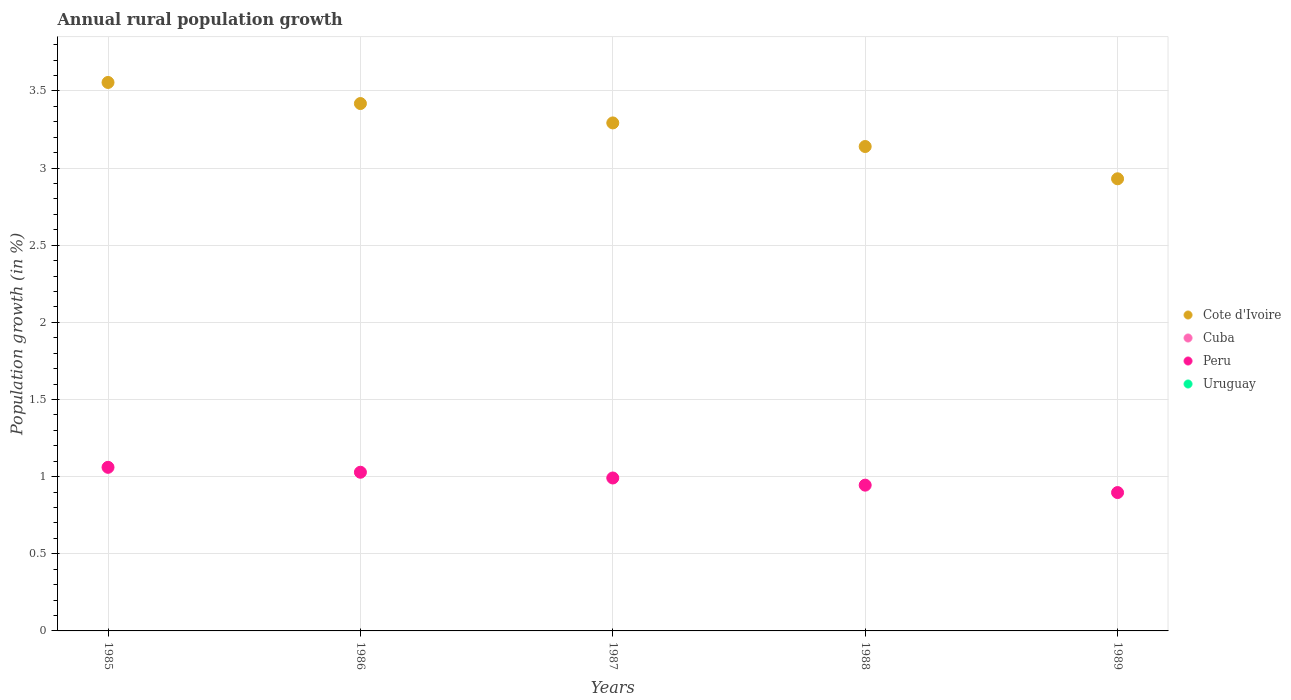How many different coloured dotlines are there?
Keep it short and to the point. 2. Is the number of dotlines equal to the number of legend labels?
Your answer should be very brief. No. Across all years, what is the maximum percentage of rural population growth in Cote d'Ivoire?
Provide a short and direct response. 3.56. Across all years, what is the minimum percentage of rural population growth in Peru?
Your answer should be compact. 0.9. In which year was the percentage of rural population growth in Cote d'Ivoire maximum?
Give a very brief answer. 1985. What is the difference between the percentage of rural population growth in Cote d'Ivoire in 1985 and that in 1989?
Your response must be concise. 0.62. What is the difference between the percentage of rural population growth in Peru in 1988 and the percentage of rural population growth in Uruguay in 1989?
Your answer should be compact. 0.94. What is the average percentage of rural population growth in Cuba per year?
Give a very brief answer. 0. In the year 1988, what is the difference between the percentage of rural population growth in Peru and percentage of rural population growth in Cote d'Ivoire?
Provide a short and direct response. -2.2. What is the ratio of the percentage of rural population growth in Peru in 1985 to that in 1988?
Provide a short and direct response. 1.12. Is the percentage of rural population growth in Cote d'Ivoire in 1985 less than that in 1989?
Keep it short and to the point. No. What is the difference between the highest and the second highest percentage of rural population growth in Cote d'Ivoire?
Keep it short and to the point. 0.14. What is the difference between the highest and the lowest percentage of rural population growth in Peru?
Your answer should be very brief. 0.16. In how many years, is the percentage of rural population growth in Cuba greater than the average percentage of rural population growth in Cuba taken over all years?
Ensure brevity in your answer.  0. Is the sum of the percentage of rural population growth in Cote d'Ivoire in 1986 and 1988 greater than the maximum percentage of rural population growth in Cuba across all years?
Provide a succinct answer. Yes. Is it the case that in every year, the sum of the percentage of rural population growth in Uruguay and percentage of rural population growth in Peru  is greater than the percentage of rural population growth in Cote d'Ivoire?
Your answer should be very brief. No. Does the percentage of rural population growth in Cote d'Ivoire monotonically increase over the years?
Your answer should be compact. No. How many years are there in the graph?
Keep it short and to the point. 5. What is the difference between two consecutive major ticks on the Y-axis?
Offer a very short reply. 0.5. Does the graph contain grids?
Your response must be concise. Yes. How are the legend labels stacked?
Give a very brief answer. Vertical. What is the title of the graph?
Offer a terse response. Annual rural population growth. Does "Guinea" appear as one of the legend labels in the graph?
Keep it short and to the point. No. What is the label or title of the X-axis?
Keep it short and to the point. Years. What is the label or title of the Y-axis?
Your answer should be very brief. Population growth (in %). What is the Population growth (in %) in Cote d'Ivoire in 1985?
Your answer should be very brief. 3.56. What is the Population growth (in %) of Cuba in 1985?
Your answer should be very brief. 0. What is the Population growth (in %) of Peru in 1985?
Your answer should be compact. 1.06. What is the Population growth (in %) of Uruguay in 1985?
Your answer should be compact. 0. What is the Population growth (in %) of Cote d'Ivoire in 1986?
Keep it short and to the point. 3.42. What is the Population growth (in %) in Cuba in 1986?
Make the answer very short. 0. What is the Population growth (in %) of Peru in 1986?
Make the answer very short. 1.03. What is the Population growth (in %) in Uruguay in 1986?
Your answer should be very brief. 0. What is the Population growth (in %) in Cote d'Ivoire in 1987?
Offer a terse response. 3.29. What is the Population growth (in %) in Peru in 1987?
Provide a short and direct response. 0.99. What is the Population growth (in %) of Cote d'Ivoire in 1988?
Provide a short and direct response. 3.14. What is the Population growth (in %) in Peru in 1988?
Make the answer very short. 0.94. What is the Population growth (in %) in Uruguay in 1988?
Ensure brevity in your answer.  0. What is the Population growth (in %) of Cote d'Ivoire in 1989?
Offer a very short reply. 2.93. What is the Population growth (in %) of Peru in 1989?
Your answer should be very brief. 0.9. What is the Population growth (in %) in Uruguay in 1989?
Your answer should be very brief. 0. Across all years, what is the maximum Population growth (in %) in Cote d'Ivoire?
Keep it short and to the point. 3.56. Across all years, what is the maximum Population growth (in %) in Peru?
Your answer should be compact. 1.06. Across all years, what is the minimum Population growth (in %) in Cote d'Ivoire?
Make the answer very short. 2.93. Across all years, what is the minimum Population growth (in %) in Peru?
Keep it short and to the point. 0.9. What is the total Population growth (in %) in Cote d'Ivoire in the graph?
Keep it short and to the point. 16.34. What is the total Population growth (in %) of Peru in the graph?
Your answer should be very brief. 4.92. What is the difference between the Population growth (in %) in Cote d'Ivoire in 1985 and that in 1986?
Give a very brief answer. 0.14. What is the difference between the Population growth (in %) in Peru in 1985 and that in 1986?
Provide a succinct answer. 0.03. What is the difference between the Population growth (in %) in Cote d'Ivoire in 1985 and that in 1987?
Your answer should be very brief. 0.26. What is the difference between the Population growth (in %) in Peru in 1985 and that in 1987?
Your response must be concise. 0.07. What is the difference between the Population growth (in %) in Cote d'Ivoire in 1985 and that in 1988?
Provide a succinct answer. 0.42. What is the difference between the Population growth (in %) in Peru in 1985 and that in 1988?
Make the answer very short. 0.12. What is the difference between the Population growth (in %) of Cote d'Ivoire in 1985 and that in 1989?
Offer a terse response. 0.62. What is the difference between the Population growth (in %) in Peru in 1985 and that in 1989?
Keep it short and to the point. 0.16. What is the difference between the Population growth (in %) of Cote d'Ivoire in 1986 and that in 1987?
Provide a succinct answer. 0.13. What is the difference between the Population growth (in %) in Peru in 1986 and that in 1987?
Your response must be concise. 0.04. What is the difference between the Population growth (in %) in Cote d'Ivoire in 1986 and that in 1988?
Keep it short and to the point. 0.28. What is the difference between the Population growth (in %) of Peru in 1986 and that in 1988?
Offer a very short reply. 0.08. What is the difference between the Population growth (in %) in Cote d'Ivoire in 1986 and that in 1989?
Keep it short and to the point. 0.49. What is the difference between the Population growth (in %) of Peru in 1986 and that in 1989?
Your answer should be compact. 0.13. What is the difference between the Population growth (in %) in Cote d'Ivoire in 1987 and that in 1988?
Make the answer very short. 0.15. What is the difference between the Population growth (in %) in Peru in 1987 and that in 1988?
Offer a terse response. 0.05. What is the difference between the Population growth (in %) in Cote d'Ivoire in 1987 and that in 1989?
Give a very brief answer. 0.36. What is the difference between the Population growth (in %) in Peru in 1987 and that in 1989?
Your answer should be very brief. 0.09. What is the difference between the Population growth (in %) of Cote d'Ivoire in 1988 and that in 1989?
Keep it short and to the point. 0.21. What is the difference between the Population growth (in %) of Peru in 1988 and that in 1989?
Your answer should be compact. 0.05. What is the difference between the Population growth (in %) of Cote d'Ivoire in 1985 and the Population growth (in %) of Peru in 1986?
Your answer should be compact. 2.53. What is the difference between the Population growth (in %) in Cote d'Ivoire in 1985 and the Population growth (in %) in Peru in 1987?
Your response must be concise. 2.56. What is the difference between the Population growth (in %) of Cote d'Ivoire in 1985 and the Population growth (in %) of Peru in 1988?
Your response must be concise. 2.61. What is the difference between the Population growth (in %) in Cote d'Ivoire in 1985 and the Population growth (in %) in Peru in 1989?
Give a very brief answer. 2.66. What is the difference between the Population growth (in %) in Cote d'Ivoire in 1986 and the Population growth (in %) in Peru in 1987?
Offer a terse response. 2.43. What is the difference between the Population growth (in %) in Cote d'Ivoire in 1986 and the Population growth (in %) in Peru in 1988?
Give a very brief answer. 2.47. What is the difference between the Population growth (in %) of Cote d'Ivoire in 1986 and the Population growth (in %) of Peru in 1989?
Your response must be concise. 2.52. What is the difference between the Population growth (in %) of Cote d'Ivoire in 1987 and the Population growth (in %) of Peru in 1988?
Keep it short and to the point. 2.35. What is the difference between the Population growth (in %) in Cote d'Ivoire in 1987 and the Population growth (in %) in Peru in 1989?
Your response must be concise. 2.4. What is the difference between the Population growth (in %) of Cote d'Ivoire in 1988 and the Population growth (in %) of Peru in 1989?
Give a very brief answer. 2.24. What is the average Population growth (in %) in Cote d'Ivoire per year?
Offer a very short reply. 3.27. What is the average Population growth (in %) in Peru per year?
Make the answer very short. 0.98. What is the average Population growth (in %) in Uruguay per year?
Ensure brevity in your answer.  0. In the year 1985, what is the difference between the Population growth (in %) of Cote d'Ivoire and Population growth (in %) of Peru?
Offer a terse response. 2.49. In the year 1986, what is the difference between the Population growth (in %) of Cote d'Ivoire and Population growth (in %) of Peru?
Your response must be concise. 2.39. In the year 1987, what is the difference between the Population growth (in %) in Cote d'Ivoire and Population growth (in %) in Peru?
Provide a short and direct response. 2.3. In the year 1988, what is the difference between the Population growth (in %) of Cote d'Ivoire and Population growth (in %) of Peru?
Your answer should be compact. 2.19. In the year 1989, what is the difference between the Population growth (in %) in Cote d'Ivoire and Population growth (in %) in Peru?
Ensure brevity in your answer.  2.03. What is the ratio of the Population growth (in %) of Cote d'Ivoire in 1985 to that in 1986?
Your answer should be very brief. 1.04. What is the ratio of the Population growth (in %) of Peru in 1985 to that in 1986?
Your response must be concise. 1.03. What is the ratio of the Population growth (in %) of Cote d'Ivoire in 1985 to that in 1987?
Keep it short and to the point. 1.08. What is the ratio of the Population growth (in %) in Peru in 1985 to that in 1987?
Your answer should be compact. 1.07. What is the ratio of the Population growth (in %) in Cote d'Ivoire in 1985 to that in 1988?
Your answer should be very brief. 1.13. What is the ratio of the Population growth (in %) in Peru in 1985 to that in 1988?
Keep it short and to the point. 1.12. What is the ratio of the Population growth (in %) in Cote d'Ivoire in 1985 to that in 1989?
Your answer should be very brief. 1.21. What is the ratio of the Population growth (in %) in Peru in 1985 to that in 1989?
Make the answer very short. 1.18. What is the ratio of the Population growth (in %) in Cote d'Ivoire in 1986 to that in 1987?
Offer a terse response. 1.04. What is the ratio of the Population growth (in %) in Peru in 1986 to that in 1987?
Offer a very short reply. 1.04. What is the ratio of the Population growth (in %) of Cote d'Ivoire in 1986 to that in 1988?
Provide a short and direct response. 1.09. What is the ratio of the Population growth (in %) of Peru in 1986 to that in 1988?
Offer a very short reply. 1.09. What is the ratio of the Population growth (in %) of Cote d'Ivoire in 1986 to that in 1989?
Keep it short and to the point. 1.17. What is the ratio of the Population growth (in %) in Peru in 1986 to that in 1989?
Provide a succinct answer. 1.15. What is the ratio of the Population growth (in %) of Cote d'Ivoire in 1987 to that in 1988?
Give a very brief answer. 1.05. What is the ratio of the Population growth (in %) in Peru in 1987 to that in 1988?
Offer a terse response. 1.05. What is the ratio of the Population growth (in %) in Cote d'Ivoire in 1987 to that in 1989?
Your response must be concise. 1.12. What is the ratio of the Population growth (in %) in Peru in 1987 to that in 1989?
Give a very brief answer. 1.11. What is the ratio of the Population growth (in %) in Cote d'Ivoire in 1988 to that in 1989?
Give a very brief answer. 1.07. What is the ratio of the Population growth (in %) in Peru in 1988 to that in 1989?
Keep it short and to the point. 1.05. What is the difference between the highest and the second highest Population growth (in %) of Cote d'Ivoire?
Offer a very short reply. 0.14. What is the difference between the highest and the second highest Population growth (in %) of Peru?
Your response must be concise. 0.03. What is the difference between the highest and the lowest Population growth (in %) of Cote d'Ivoire?
Your response must be concise. 0.62. What is the difference between the highest and the lowest Population growth (in %) of Peru?
Provide a succinct answer. 0.16. 